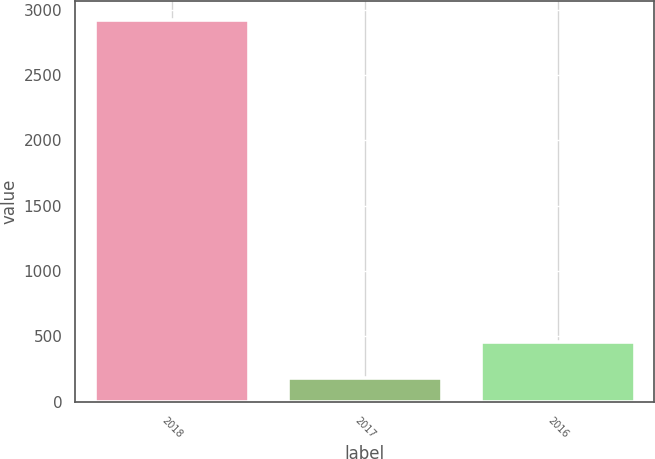Convert chart. <chart><loc_0><loc_0><loc_500><loc_500><bar_chart><fcel>2018<fcel>2017<fcel>2016<nl><fcel>2920<fcel>185<fcel>458.5<nl></chart> 